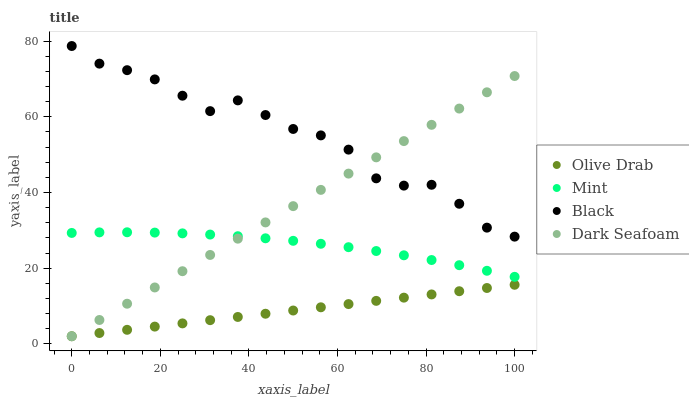Does Olive Drab have the minimum area under the curve?
Answer yes or no. Yes. Does Black have the maximum area under the curve?
Answer yes or no. Yes. Does Dark Seafoam have the minimum area under the curve?
Answer yes or no. No. Does Dark Seafoam have the maximum area under the curve?
Answer yes or no. No. Is Olive Drab the smoothest?
Answer yes or no. Yes. Is Black the roughest?
Answer yes or no. Yes. Is Dark Seafoam the smoothest?
Answer yes or no. No. Is Dark Seafoam the roughest?
Answer yes or no. No. Does Dark Seafoam have the lowest value?
Answer yes or no. Yes. Does Mint have the lowest value?
Answer yes or no. No. Does Black have the highest value?
Answer yes or no. Yes. Does Dark Seafoam have the highest value?
Answer yes or no. No. Is Mint less than Black?
Answer yes or no. Yes. Is Black greater than Olive Drab?
Answer yes or no. Yes. Does Dark Seafoam intersect Black?
Answer yes or no. Yes. Is Dark Seafoam less than Black?
Answer yes or no. No. Is Dark Seafoam greater than Black?
Answer yes or no. No. Does Mint intersect Black?
Answer yes or no. No. 